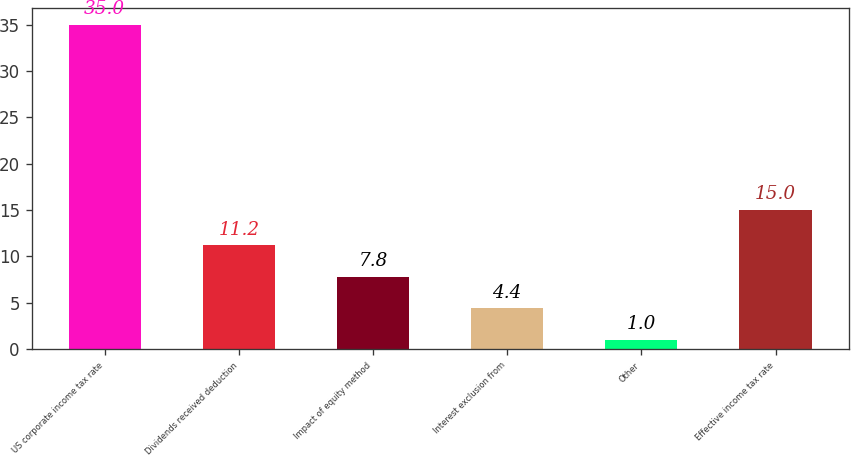<chart> <loc_0><loc_0><loc_500><loc_500><bar_chart><fcel>US corporate income tax rate<fcel>Dividends received deduction<fcel>Impact of equity method<fcel>Interest exclusion from<fcel>Other<fcel>Effective income tax rate<nl><fcel>35<fcel>11.2<fcel>7.8<fcel>4.4<fcel>1<fcel>15<nl></chart> 